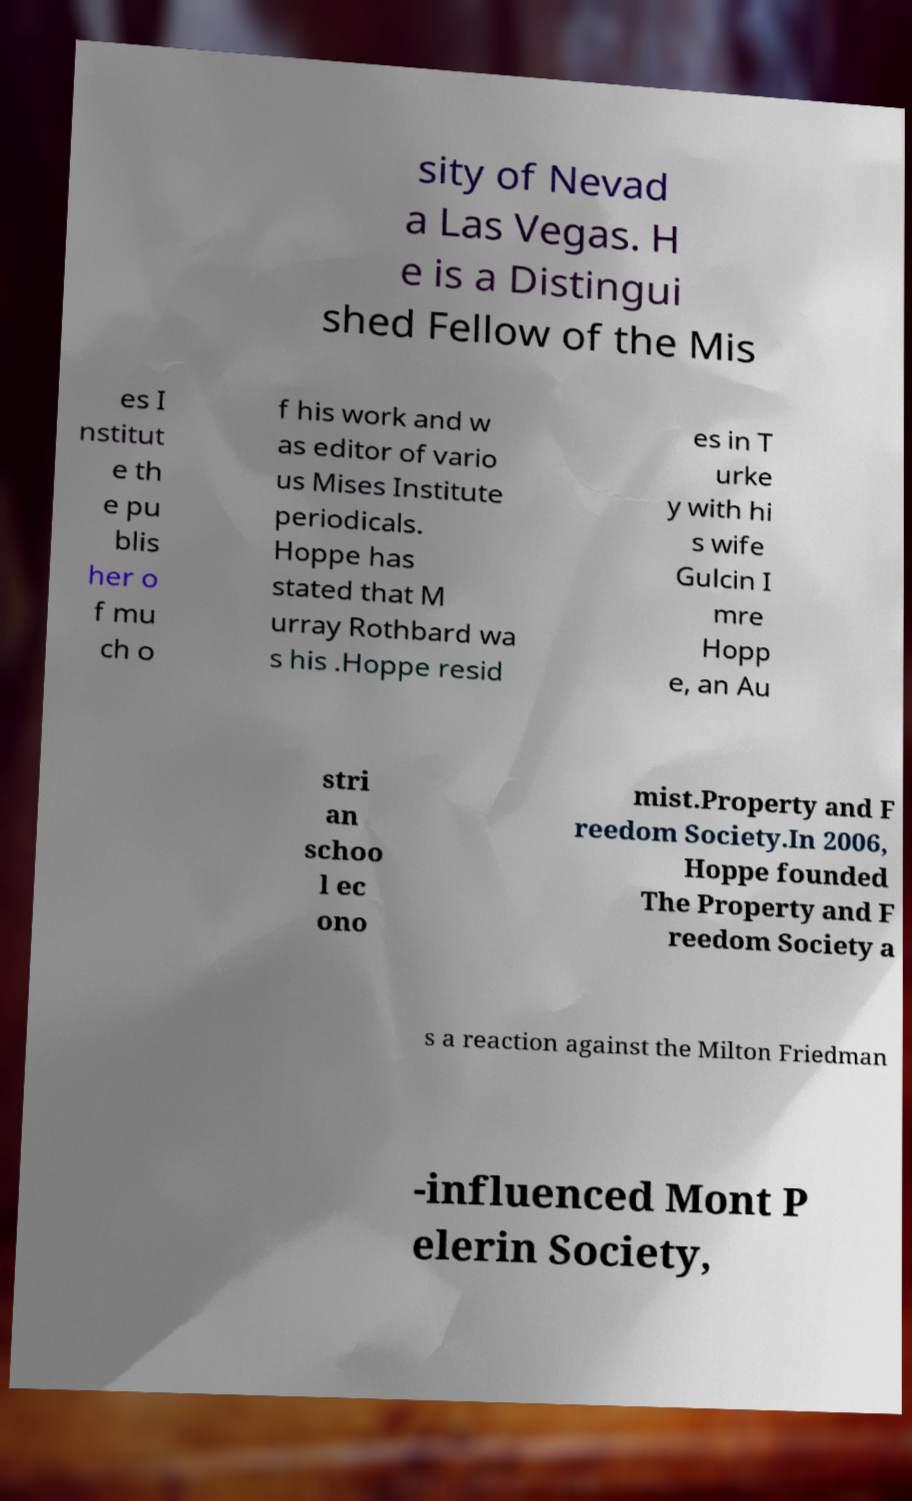Could you assist in decoding the text presented in this image and type it out clearly? sity of Nevad a Las Vegas. H e is a Distingui shed Fellow of the Mis es I nstitut e th e pu blis her o f mu ch o f his work and w as editor of vario us Mises Institute periodicals. Hoppe has stated that M urray Rothbard wa s his .Hoppe resid es in T urke y with hi s wife Gulcin I mre Hopp e, an Au stri an schoo l ec ono mist.Property and F reedom Society.In 2006, Hoppe founded The Property and F reedom Society a s a reaction against the Milton Friedman -influenced Mont P elerin Society, 